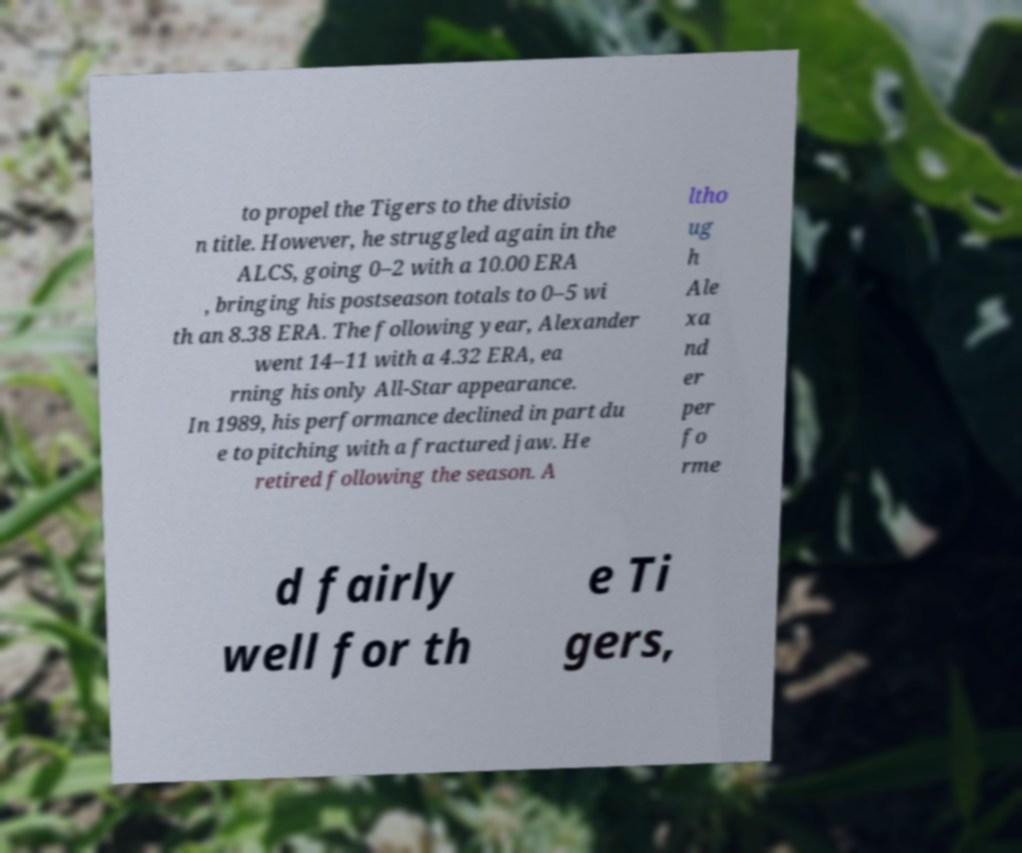Please read and relay the text visible in this image. What does it say? to propel the Tigers to the divisio n title. However, he struggled again in the ALCS, going 0–2 with a 10.00 ERA , bringing his postseason totals to 0–5 wi th an 8.38 ERA. The following year, Alexander went 14–11 with a 4.32 ERA, ea rning his only All-Star appearance. In 1989, his performance declined in part du e to pitching with a fractured jaw. He retired following the season. A ltho ug h Ale xa nd er per fo rme d fairly well for th e Ti gers, 